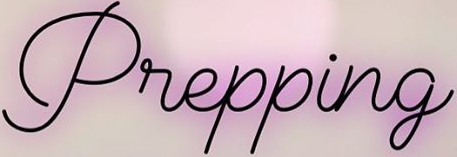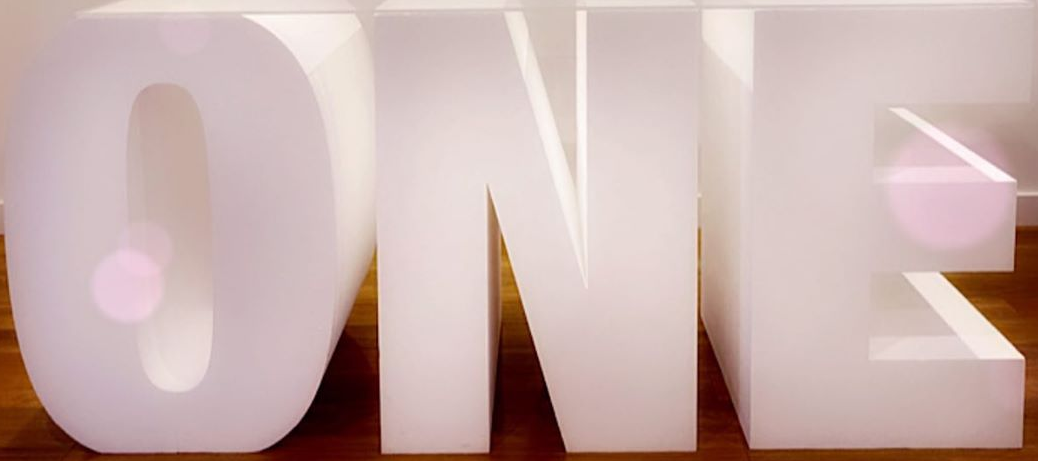What text is displayed in these images sequentially, separated by a semicolon? Prepping; ONE 